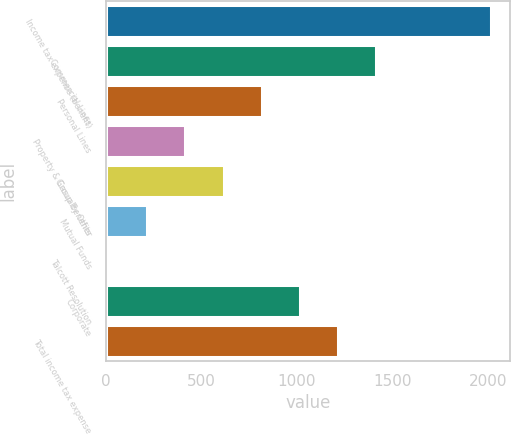Convert chart to OTSL. <chart><loc_0><loc_0><loc_500><loc_500><bar_chart><fcel>Income tax expense (benefit)<fcel>Commercial Lines<fcel>Personal Lines<fcel>Property & Casualty Other<fcel>Group Benefits<fcel>Mutual Funds<fcel>Talcott Resolution<fcel>Corporate<fcel>Total income tax expense<nl><fcel>2014<fcel>1414.6<fcel>815.2<fcel>415.6<fcel>615.4<fcel>215.8<fcel>16<fcel>1015<fcel>1214.8<nl></chart> 